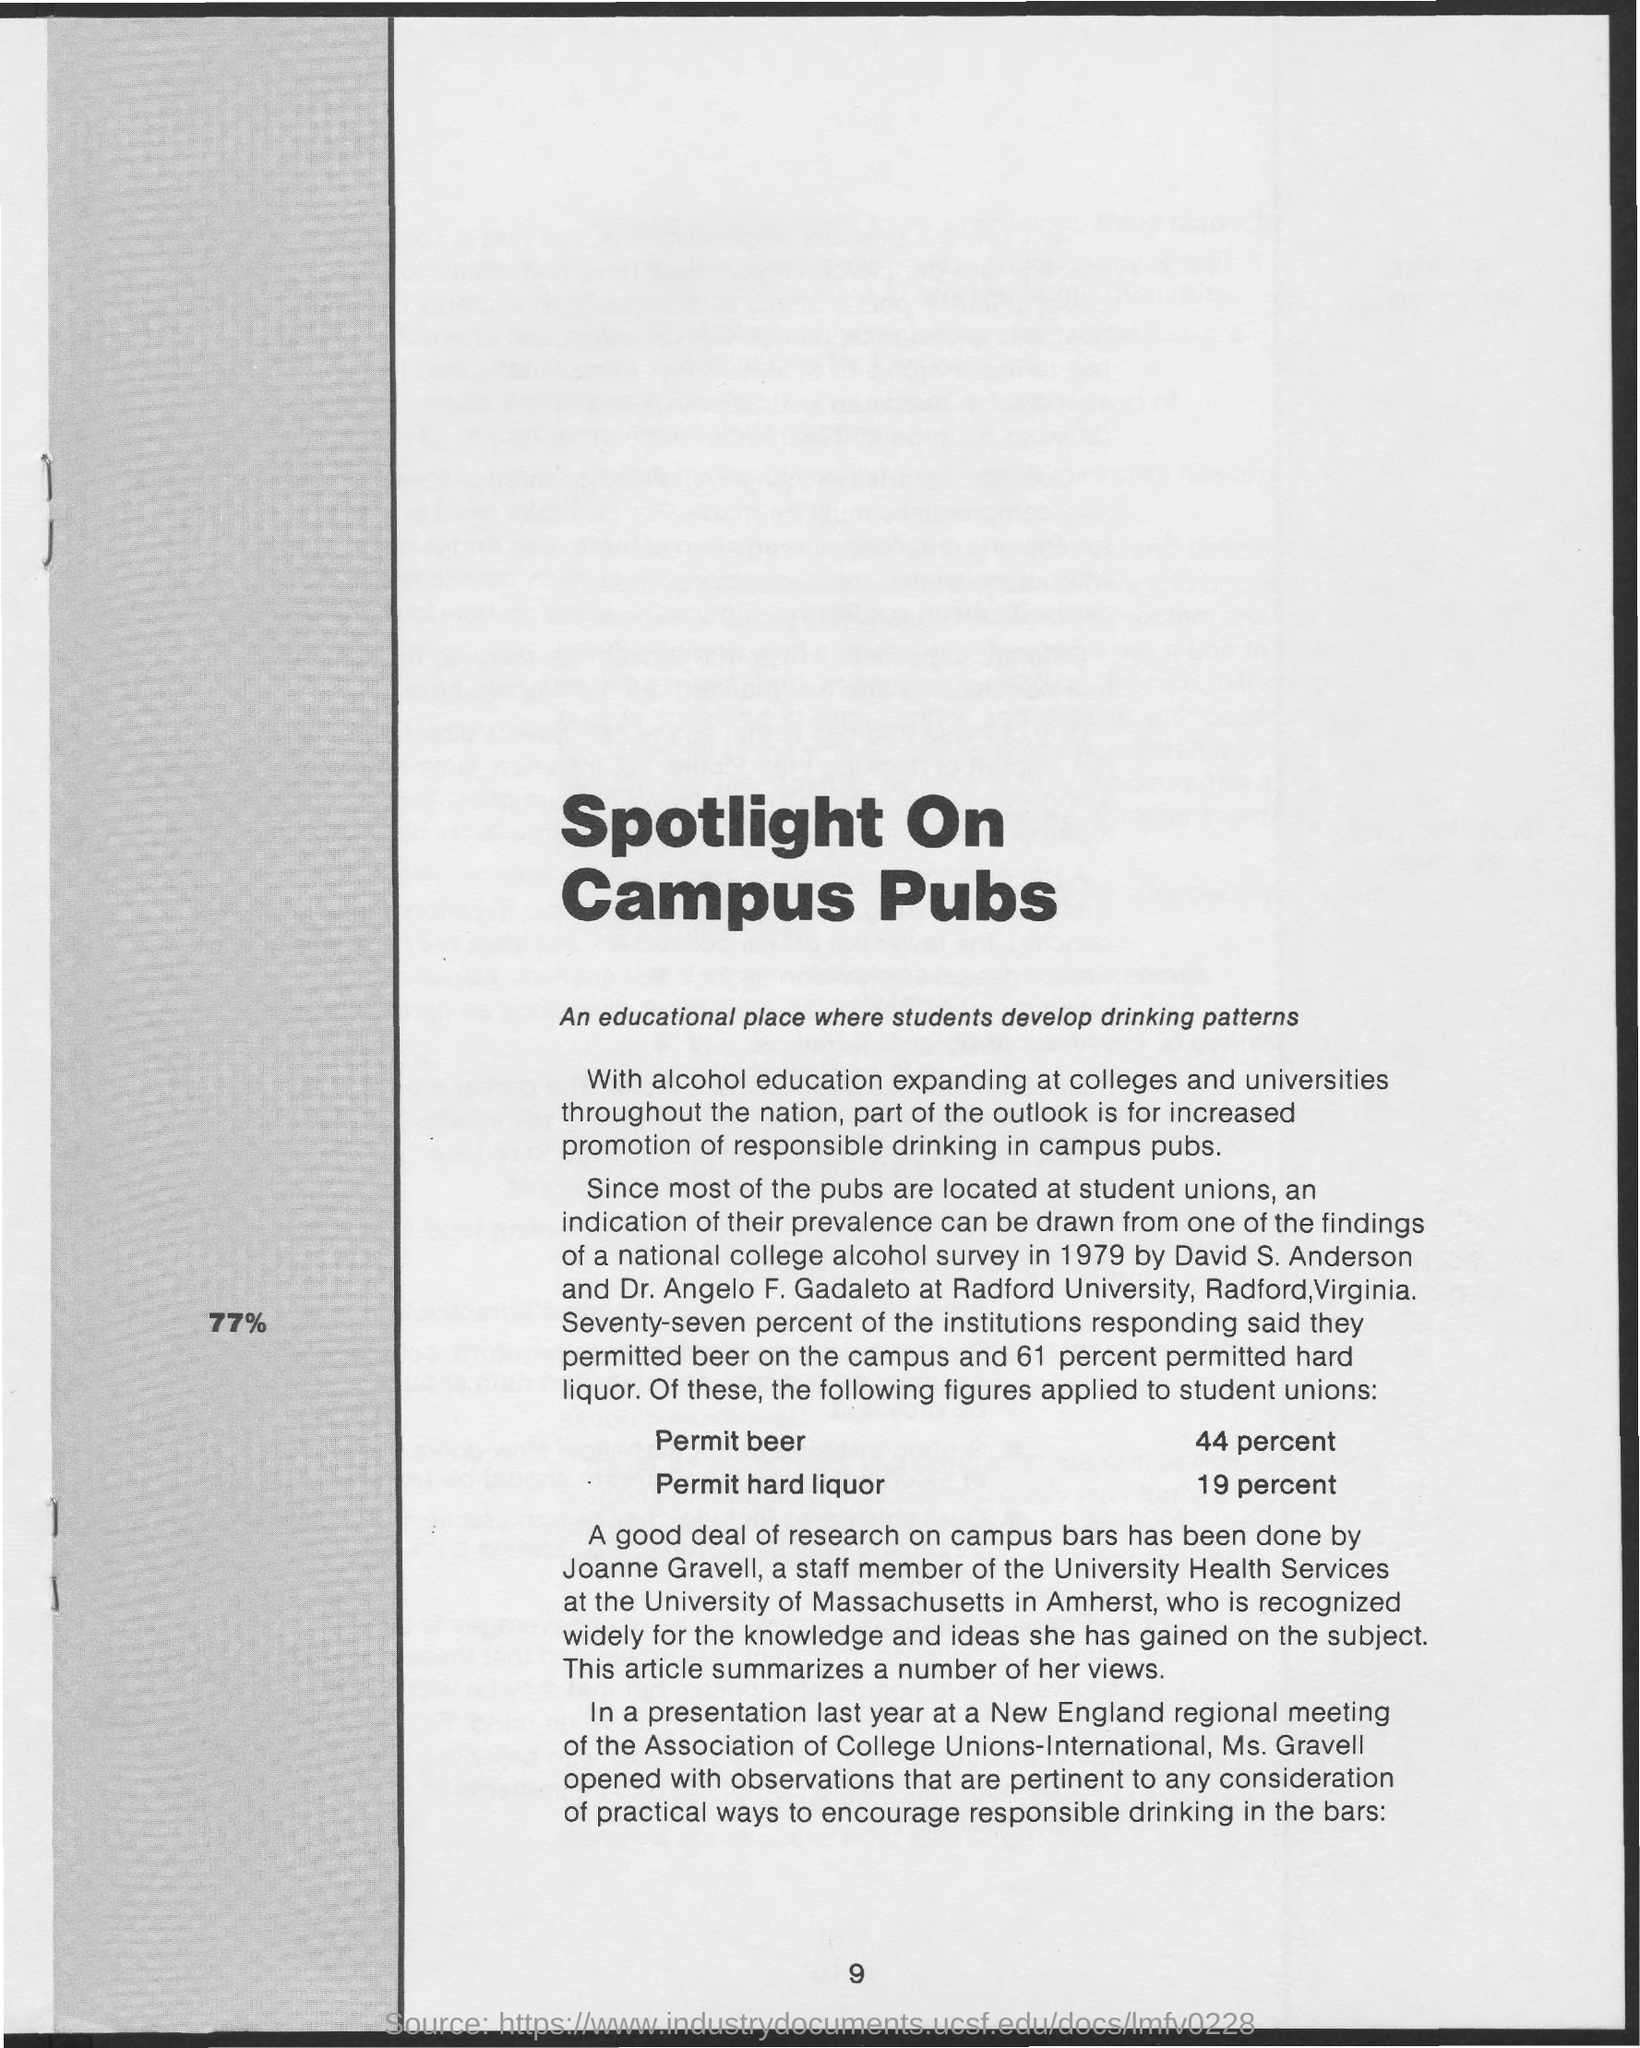Draw attention to some important aspects in this diagram. The permit percentage of beer is 44 percent. The title of the page is "Spotlight on Campus Pubs. The permit percentage of hard liquor is 19%. The title "Spotlight on Campus Pubs" highlights the educational aspect of how students develop their drinking patterns on campus, with a focus on the impact of these patterns on their overall academic performance. The page number at the bottom of the page is 9. 